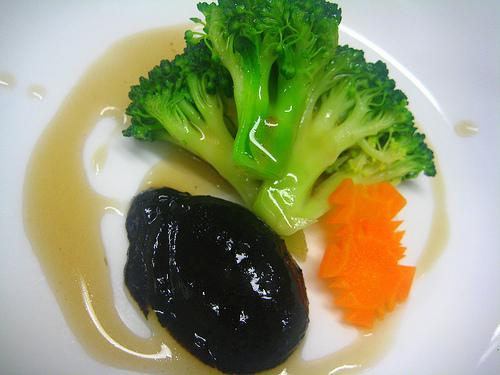Question: how many food types are on the plate?
Choices:
A. Four.
B. Three.
C. Two.
D. Five.
Answer with the letter. Answer: B Question: what color are the carrots?
Choices:
A. Orange.
B. Red.
C. Yellow.
D. Black.
Answer with the letter. Answer: A Question: how much broccoli is on the plate?
Choices:
A. 1 spear.
B. Three florets.
C. 2 spears.
D. 4 spears.
Answer with the letter. Answer: B 